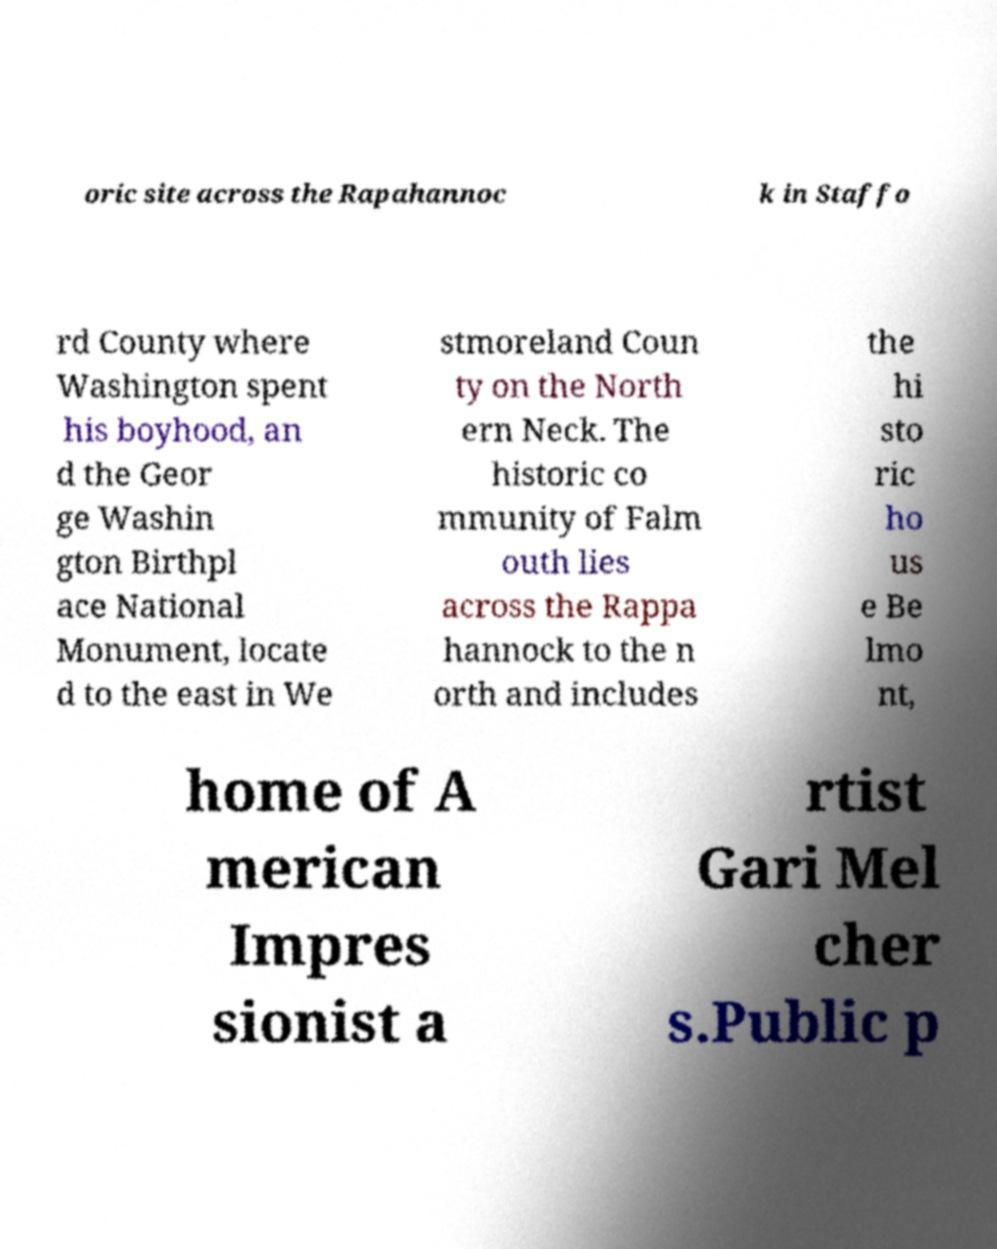Could you extract and type out the text from this image? oric site across the Rapahannoc k in Staffo rd County where Washington spent his boyhood, an d the Geor ge Washin gton Birthpl ace National Monument, locate d to the east in We stmoreland Coun ty on the North ern Neck. The historic co mmunity of Falm outh lies across the Rappa hannock to the n orth and includes the hi sto ric ho us e Be lmo nt, home of A merican Impres sionist a rtist Gari Mel cher s.Public p 